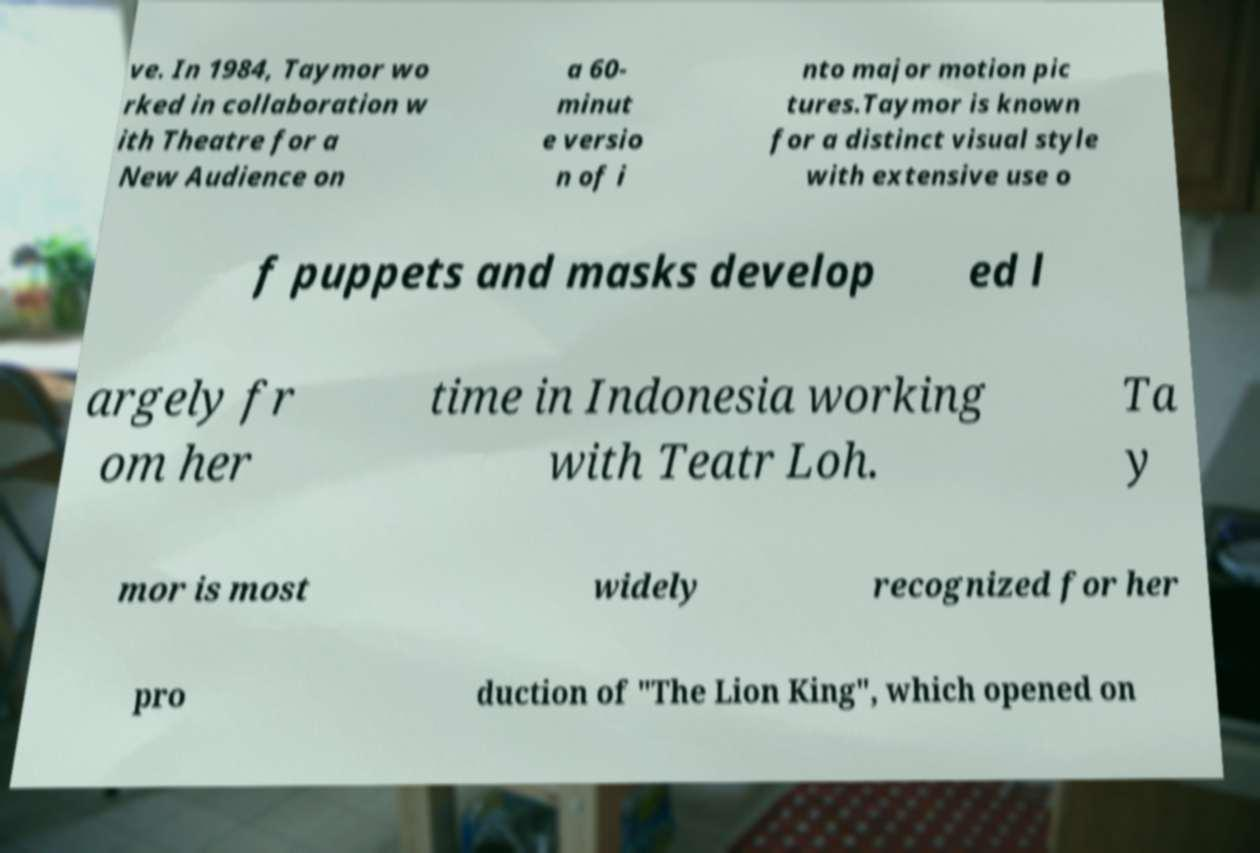Could you extract and type out the text from this image? ve. In 1984, Taymor wo rked in collaboration w ith Theatre for a New Audience on a 60- minut e versio n of i nto major motion pic tures.Taymor is known for a distinct visual style with extensive use o f puppets and masks develop ed l argely fr om her time in Indonesia working with Teatr Loh. Ta y mor is most widely recognized for her pro duction of "The Lion King", which opened on 